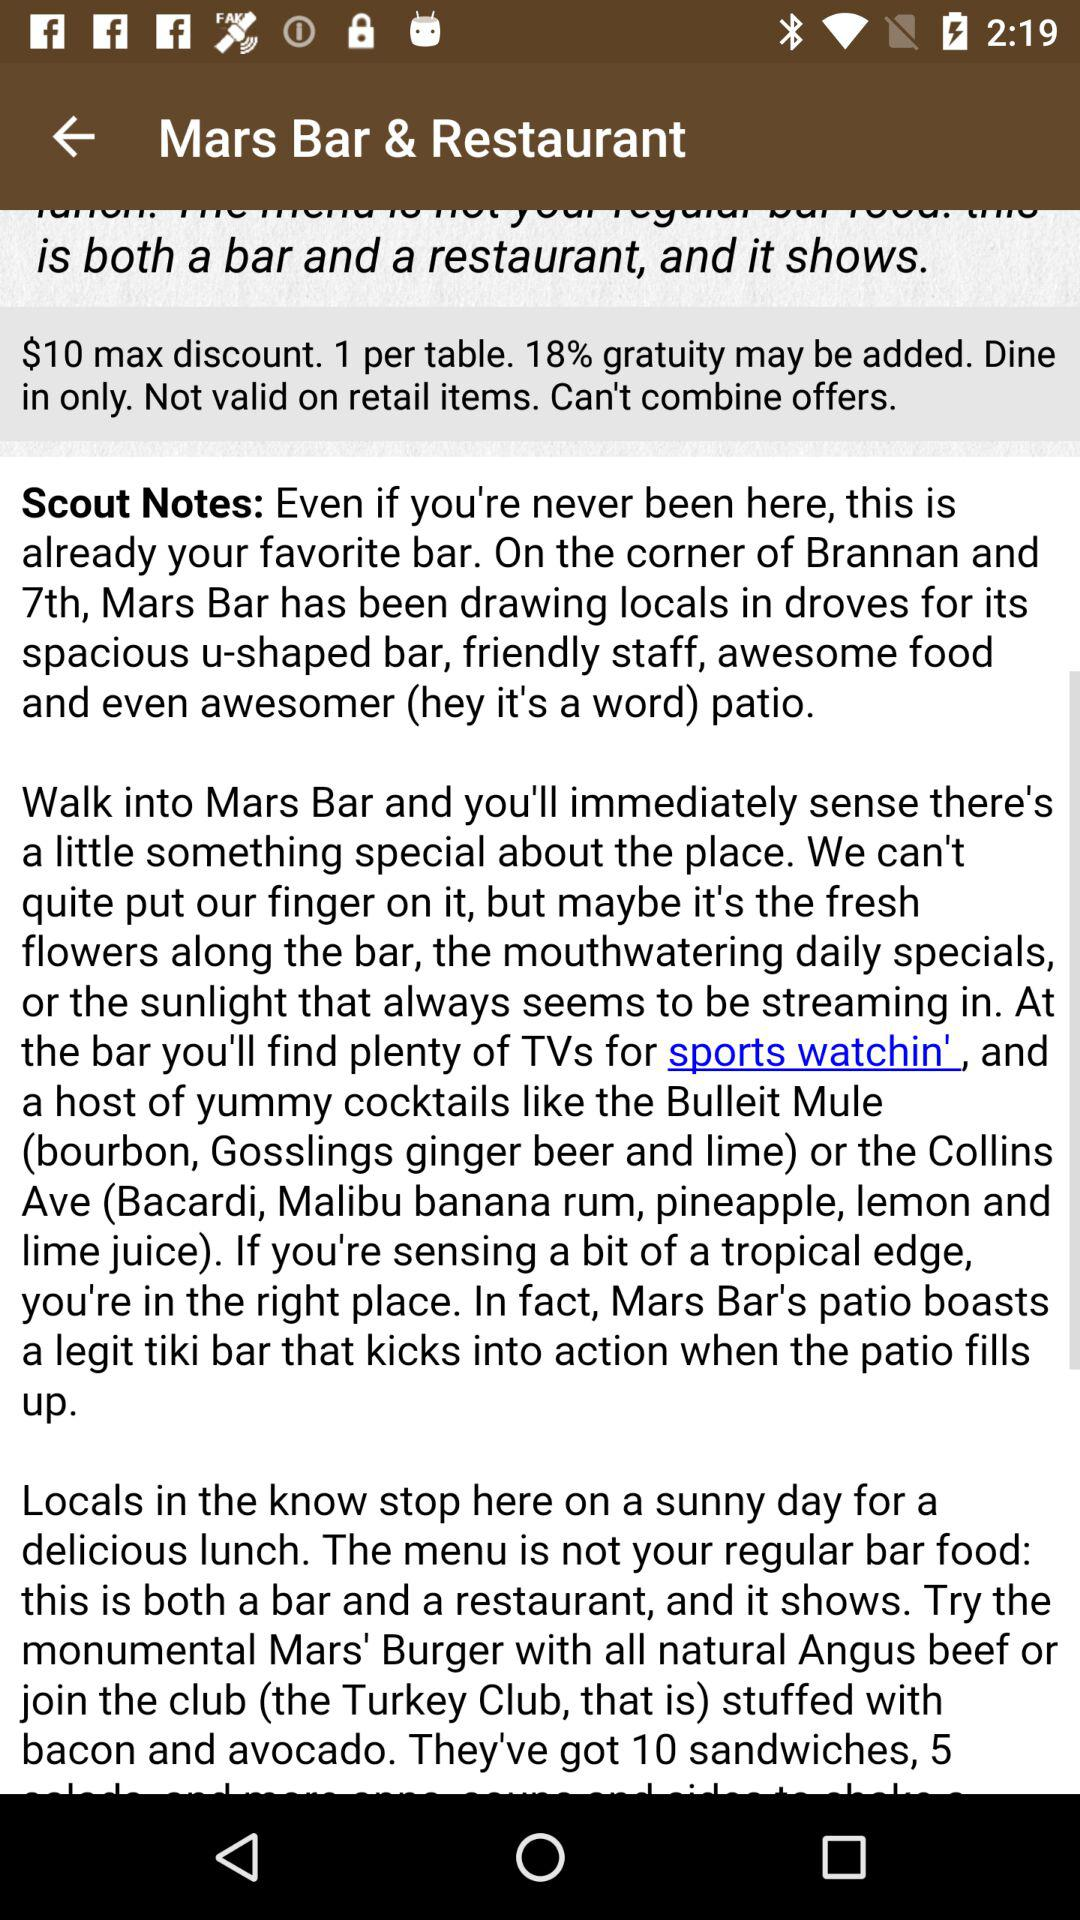What are the names of the cocktails available at "Mars Bar & Restaurant"? The names of the cocktails are "the Bulleit Mule" and "the Collins Ave". 